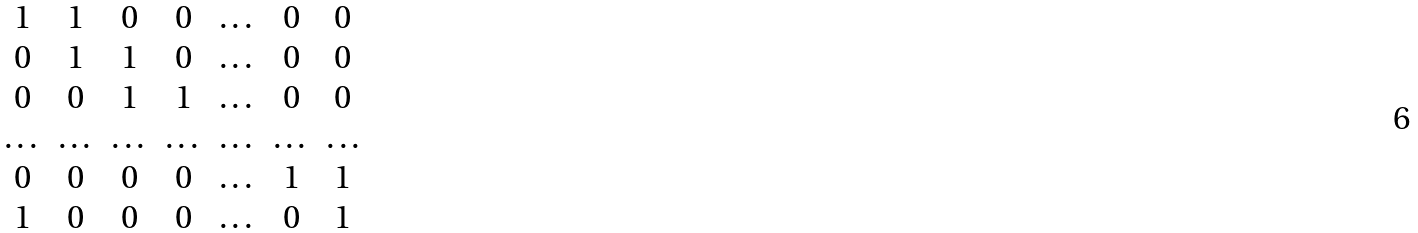<formula> <loc_0><loc_0><loc_500><loc_500>\begin{matrix} 1 & 1 & 0 & 0 & \dots & 0 & 0 \\ 0 & 1 & 1 & 0 & \dots & 0 & 0 \\ 0 & 0 & 1 & 1 & \dots & 0 & 0 \\ \dots & \dots & \dots & \dots & \dots & \dots & \dots \\ 0 & 0 & 0 & 0 & \dots & 1 & 1 \\ 1 & 0 & 0 & 0 & \dots & 0 & 1 \\ \end{matrix}</formula> 